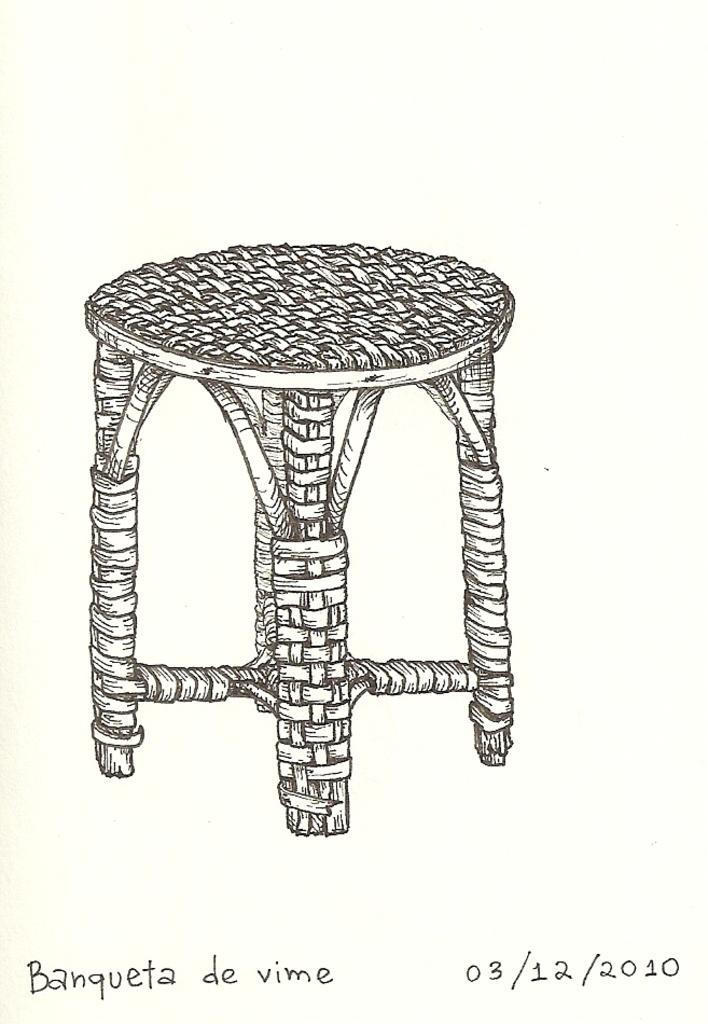Can you describe this image briefly? In this picture I can see the text at the bottom, in the middle there is a diagram of a stool. 